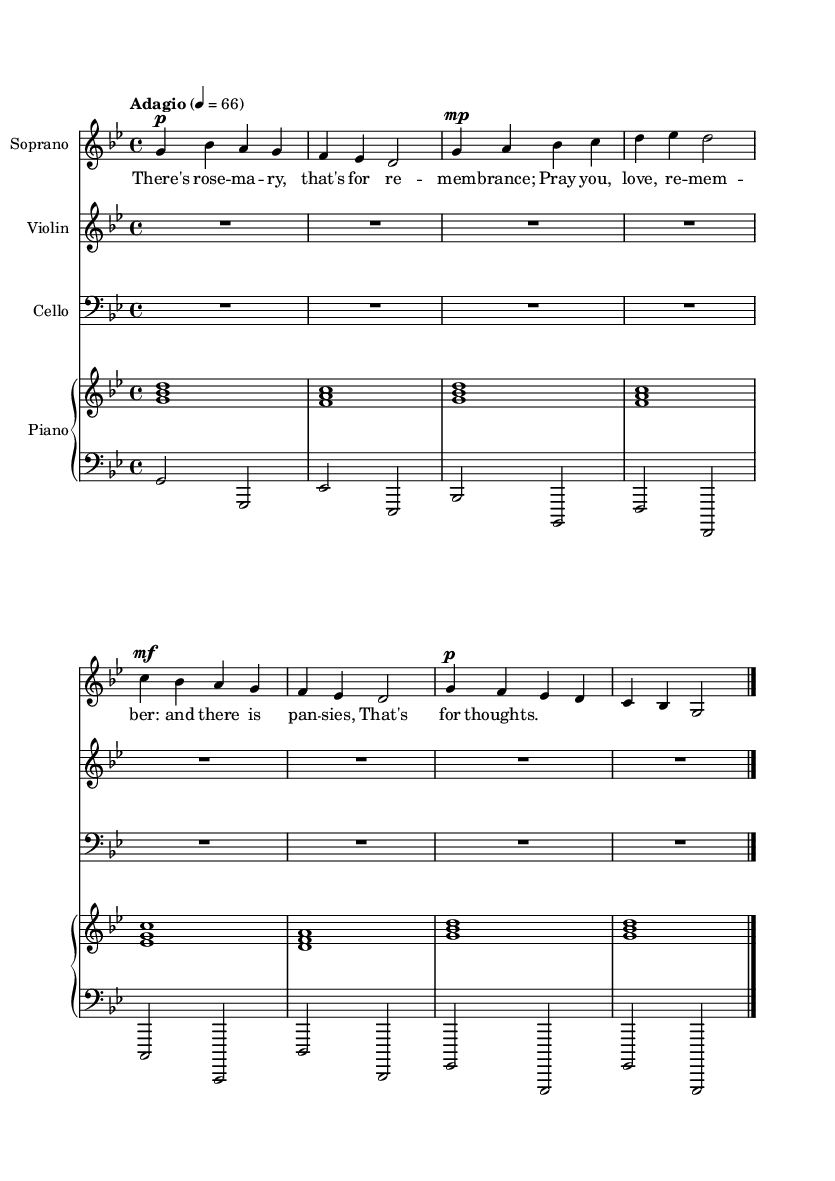What is the key signature of this music? The key signature is indicated by the presence of flats or sharps at the beginning of the staff. Here, there are B flat and E flat, which indicates that the key is G minor.
Answer: G minor What is the time signature of this piece? The time signature is found at the beginning of the staff, represented as a fraction. Here, it shows 4/4, meaning there are four beats per measure.
Answer: 4/4 What is the tempo marking for this music? The tempo marking is written near the beginning of the score, stating "Adagio" and indicating a beat of 66 per quarter note.
Answer: Adagio, 66 How many measures are in the soprano part? The soprano part is divided into measures (bars), which are indicated by vertical lines. Counting the measures shows there are eight in total up to the final bar line.
Answer: 8 Which instruments are present in this score? The instruments are listed at the top of each staff, which includes Soprano, Violin, Cello, and Piano.
Answer: Soprano, Violin, Cello, Piano What is the dynamic marking for the first measure of the soprano part? The dynamic marking indicates the volume at which to play. In the first measure, it is marked as piano, which instructs the performer to play softly.
Answer: Piano 